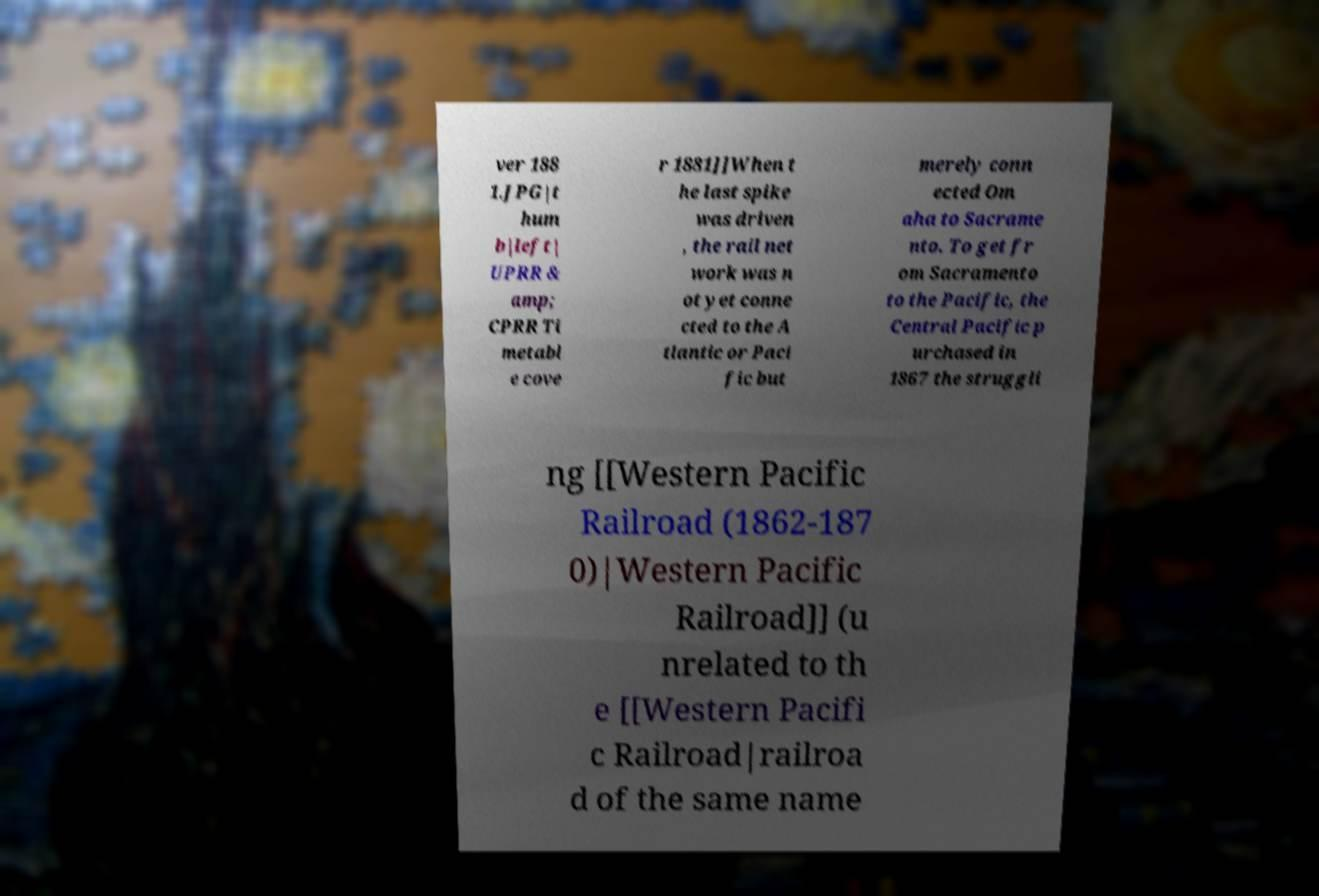Can you accurately transcribe the text from the provided image for me? ver 188 1.JPG|t hum b|left| UPRR & amp; CPRR Ti metabl e cove r 1881]]When t he last spike was driven , the rail net work was n ot yet conne cted to the A tlantic or Paci fic but merely conn ected Om aha to Sacrame nto. To get fr om Sacramento to the Pacific, the Central Pacific p urchased in 1867 the struggli ng [[Western Pacific Railroad (1862-187 0)|Western Pacific Railroad]] (u nrelated to th e [[Western Pacifi c Railroad|railroa d of the same name 